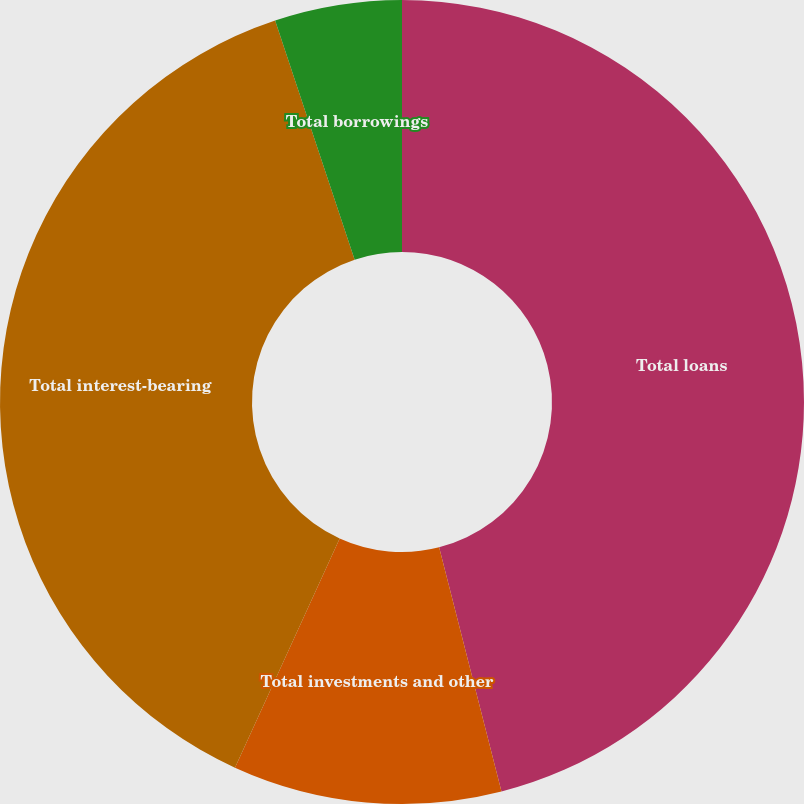<chart> <loc_0><loc_0><loc_500><loc_500><pie_chart><fcel>Total loans<fcel>Total investments and other<fcel>Total interest-bearing<fcel>Total borrowings<nl><fcel>46.02%<fcel>10.8%<fcel>38.07%<fcel>5.11%<nl></chart> 